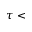<formula> <loc_0><loc_0><loc_500><loc_500>\tau <</formula> 